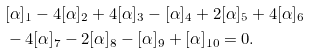Convert formula to latex. <formula><loc_0><loc_0><loc_500><loc_500>& [ \alpha ] _ { 1 } - 4 [ \alpha ] _ { 2 } + 4 [ \alpha ] _ { 3 } - [ \alpha ] _ { 4 } + 2 [ \alpha ] _ { 5 } + 4 [ \alpha ] _ { 6 } \\ & - 4 [ \alpha ] _ { 7 } - 2 [ \alpha ] _ { 8 } - [ \alpha ] _ { 9 } + [ \alpha ] _ { 1 0 } = 0 .</formula> 